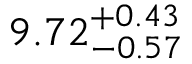<formula> <loc_0><loc_0><loc_500><loc_500>9 . 7 2 _ { - 0 . 5 7 } ^ { + 0 . 4 3 }</formula> 